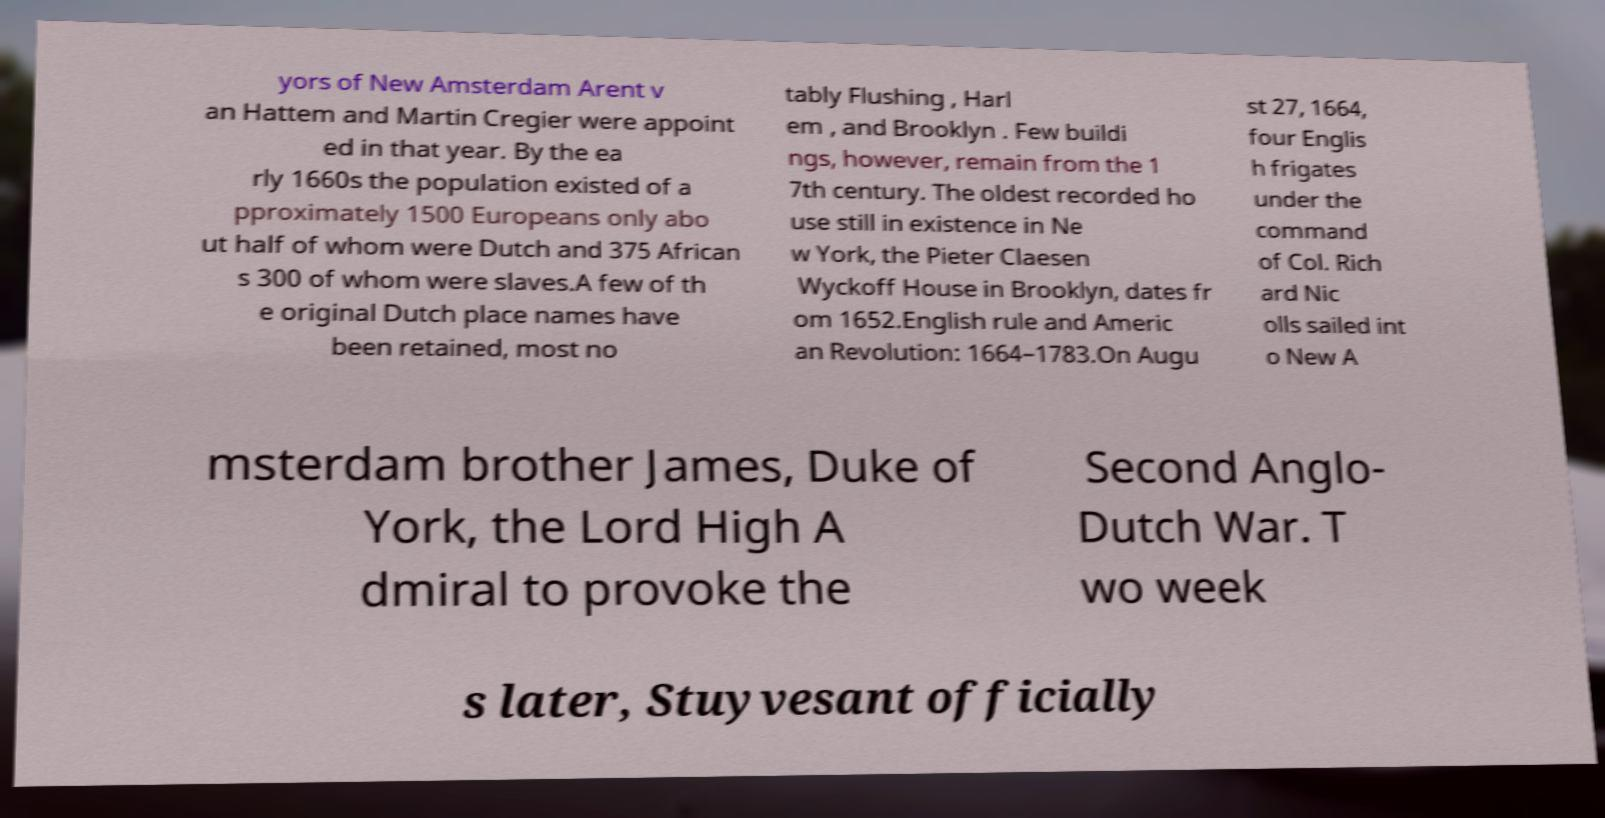Please identify and transcribe the text found in this image. yors of New Amsterdam Arent v an Hattem and Martin Cregier were appoint ed in that year. By the ea rly 1660s the population existed of a pproximately 1500 Europeans only abo ut half of whom were Dutch and 375 African s 300 of whom were slaves.A few of th e original Dutch place names have been retained, most no tably Flushing , Harl em , and Brooklyn . Few buildi ngs, however, remain from the 1 7th century. The oldest recorded ho use still in existence in Ne w York, the Pieter Claesen Wyckoff House in Brooklyn, dates fr om 1652.English rule and Americ an Revolution: 1664–1783.On Augu st 27, 1664, four Englis h frigates under the command of Col. Rich ard Nic olls sailed int o New A msterdam brother James, Duke of York, the Lord High A dmiral to provoke the Second Anglo- Dutch War. T wo week s later, Stuyvesant officially 